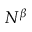Convert formula to latex. <formula><loc_0><loc_0><loc_500><loc_500>N ^ { \beta }</formula> 